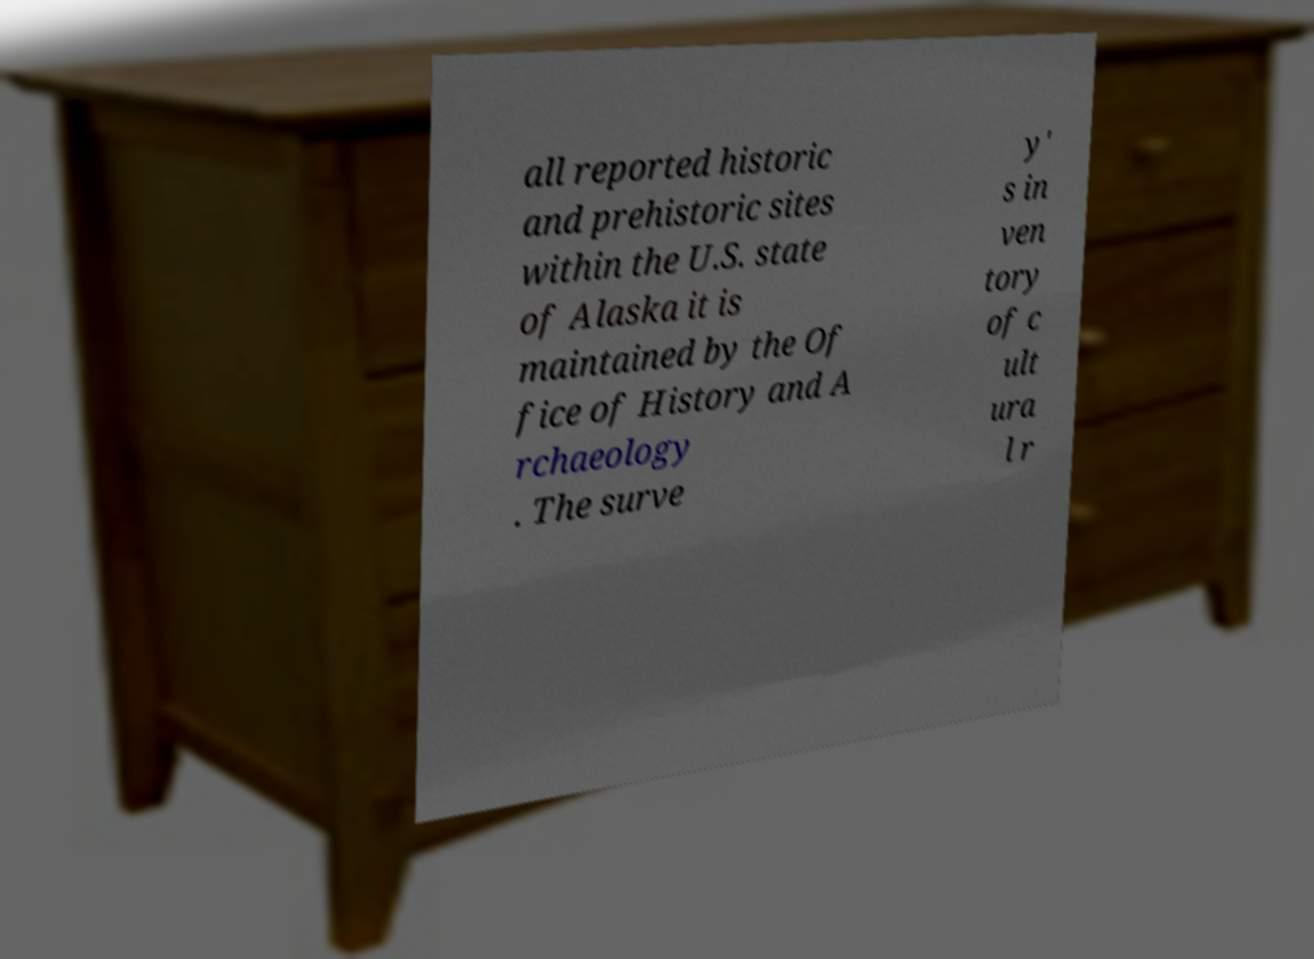I need the written content from this picture converted into text. Can you do that? all reported historic and prehistoric sites within the U.S. state of Alaska it is maintained by the Of fice of History and A rchaeology . The surve y' s in ven tory of c ult ura l r 